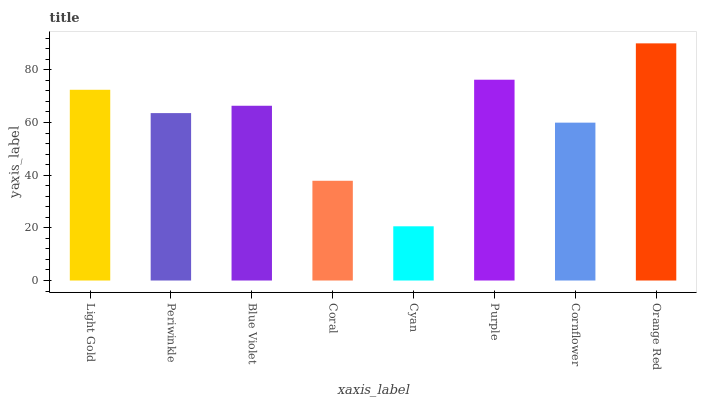Is Cyan the minimum?
Answer yes or no. Yes. Is Orange Red the maximum?
Answer yes or no. Yes. Is Periwinkle the minimum?
Answer yes or no. No. Is Periwinkle the maximum?
Answer yes or no. No. Is Light Gold greater than Periwinkle?
Answer yes or no. Yes. Is Periwinkle less than Light Gold?
Answer yes or no. Yes. Is Periwinkle greater than Light Gold?
Answer yes or no. No. Is Light Gold less than Periwinkle?
Answer yes or no. No. Is Blue Violet the high median?
Answer yes or no. Yes. Is Periwinkle the low median?
Answer yes or no. Yes. Is Orange Red the high median?
Answer yes or no. No. Is Blue Violet the low median?
Answer yes or no. No. 